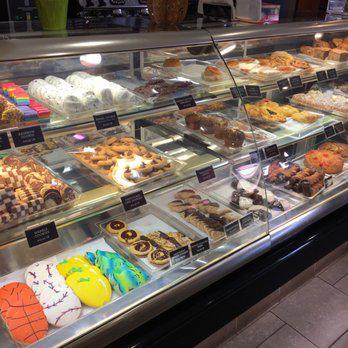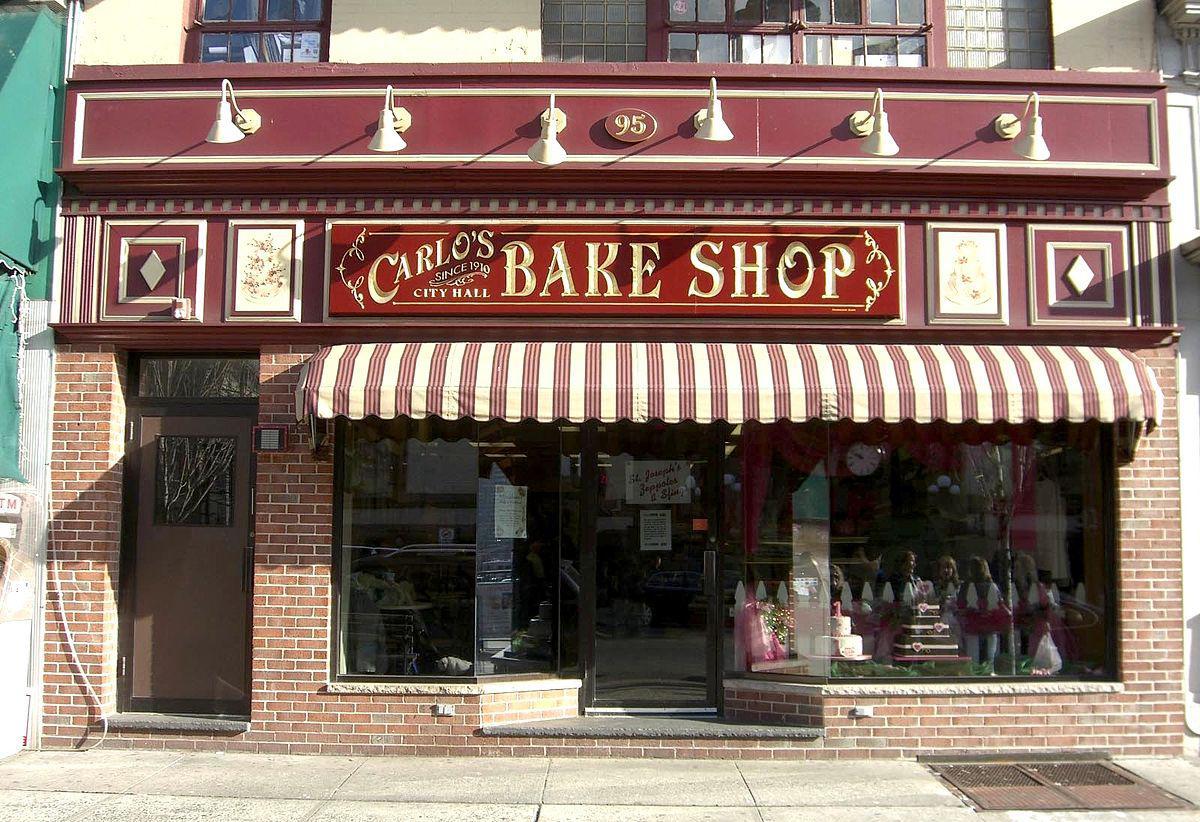The first image is the image on the left, the second image is the image on the right. Analyze the images presented: Is the assertion "There is a shoppe entrance with a striped awning." valid? Answer yes or no. Yes. 